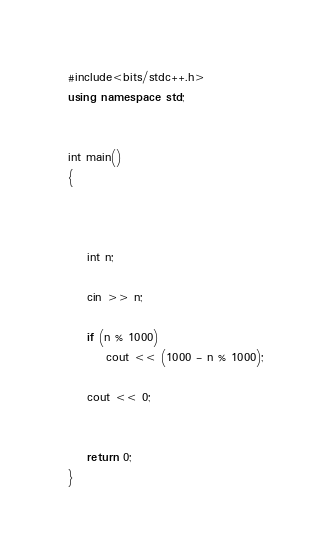Convert code to text. <code><loc_0><loc_0><loc_500><loc_500><_C++_>#include<bits/stdc++.h>
using namespace std;


int main()
{



	int n;

	cin >> n;

	if (n % 1000)
		cout << (1000 - n % 1000);

	cout << 0;


	return 0;
}</code> 